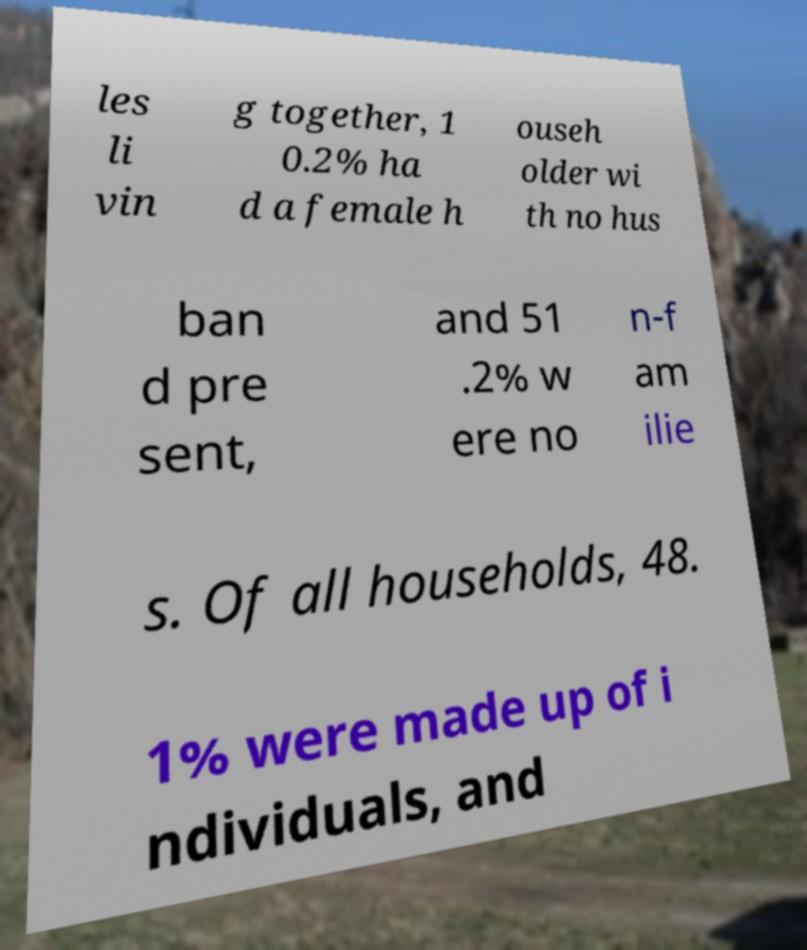There's text embedded in this image that I need extracted. Can you transcribe it verbatim? les li vin g together, 1 0.2% ha d a female h ouseh older wi th no hus ban d pre sent, and 51 .2% w ere no n-f am ilie s. Of all households, 48. 1% were made up of i ndividuals, and 